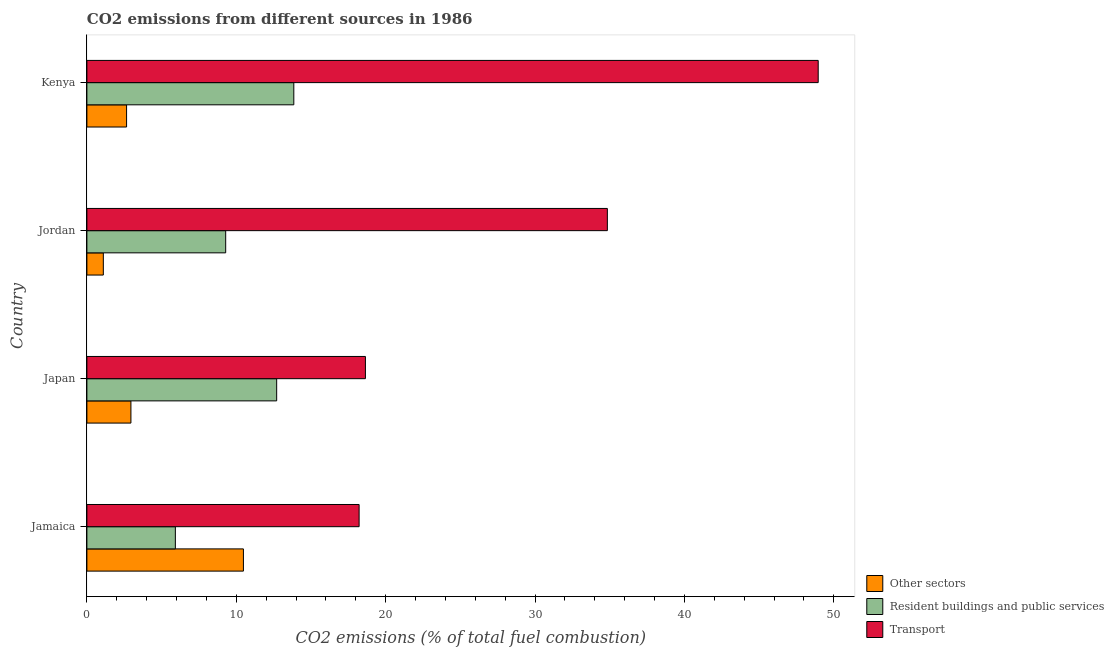How many different coloured bars are there?
Ensure brevity in your answer.  3. How many groups of bars are there?
Keep it short and to the point. 4. Are the number of bars on each tick of the Y-axis equal?
Make the answer very short. Yes. How many bars are there on the 1st tick from the bottom?
Offer a very short reply. 3. In how many cases, is the number of bars for a given country not equal to the number of legend labels?
Offer a very short reply. 0. What is the percentage of co2 emissions from other sectors in Jordan?
Give a very brief answer. 1.1. Across all countries, what is the maximum percentage of co2 emissions from transport?
Your response must be concise. 48.96. Across all countries, what is the minimum percentage of co2 emissions from other sectors?
Provide a short and direct response. 1.1. In which country was the percentage of co2 emissions from resident buildings and public services maximum?
Make the answer very short. Kenya. In which country was the percentage of co2 emissions from resident buildings and public services minimum?
Give a very brief answer. Jamaica. What is the total percentage of co2 emissions from resident buildings and public services in the graph?
Make the answer very short. 41.77. What is the difference between the percentage of co2 emissions from resident buildings and public services in Japan and that in Kenya?
Your answer should be compact. -1.15. What is the difference between the percentage of co2 emissions from resident buildings and public services in Kenya and the percentage of co2 emissions from transport in Jamaica?
Offer a very short reply. -4.37. What is the average percentage of co2 emissions from resident buildings and public services per country?
Keep it short and to the point. 10.44. What is the difference between the percentage of co2 emissions from transport and percentage of co2 emissions from resident buildings and public services in Japan?
Keep it short and to the point. 5.94. What is the ratio of the percentage of co2 emissions from resident buildings and public services in Jordan to that in Kenya?
Provide a short and direct response. 0.67. What is the difference between the highest and the second highest percentage of co2 emissions from other sectors?
Offer a very short reply. 7.53. What is the difference between the highest and the lowest percentage of co2 emissions from transport?
Keep it short and to the point. 30.73. In how many countries, is the percentage of co2 emissions from resident buildings and public services greater than the average percentage of co2 emissions from resident buildings and public services taken over all countries?
Offer a terse response. 2. What does the 2nd bar from the top in Jordan represents?
Make the answer very short. Resident buildings and public services. What does the 2nd bar from the bottom in Jordan represents?
Provide a short and direct response. Resident buildings and public services. How many bars are there?
Give a very brief answer. 12. Are all the bars in the graph horizontal?
Offer a very short reply. Yes. Does the graph contain any zero values?
Provide a short and direct response. No. Where does the legend appear in the graph?
Offer a terse response. Bottom right. How many legend labels are there?
Your response must be concise. 3. How are the legend labels stacked?
Your response must be concise. Vertical. What is the title of the graph?
Keep it short and to the point. CO2 emissions from different sources in 1986. What is the label or title of the X-axis?
Your response must be concise. CO2 emissions (% of total fuel combustion). What is the label or title of the Y-axis?
Make the answer very short. Country. What is the CO2 emissions (% of total fuel combustion) in Other sectors in Jamaica?
Offer a terse response. 10.48. What is the CO2 emissions (% of total fuel combustion) of Resident buildings and public services in Jamaica?
Your answer should be compact. 5.92. What is the CO2 emissions (% of total fuel combustion) of Transport in Jamaica?
Offer a terse response. 18.22. What is the CO2 emissions (% of total fuel combustion) in Other sectors in Japan?
Make the answer very short. 2.95. What is the CO2 emissions (% of total fuel combustion) in Resident buildings and public services in Japan?
Your answer should be very brief. 12.7. What is the CO2 emissions (% of total fuel combustion) in Transport in Japan?
Offer a terse response. 18.65. What is the CO2 emissions (% of total fuel combustion) of Other sectors in Jordan?
Provide a short and direct response. 1.1. What is the CO2 emissions (% of total fuel combustion) in Resident buildings and public services in Jordan?
Your response must be concise. 9.29. What is the CO2 emissions (% of total fuel combustion) in Transport in Jordan?
Make the answer very short. 34.84. What is the CO2 emissions (% of total fuel combustion) of Other sectors in Kenya?
Ensure brevity in your answer.  2.66. What is the CO2 emissions (% of total fuel combustion) of Resident buildings and public services in Kenya?
Your response must be concise. 13.85. What is the CO2 emissions (% of total fuel combustion) of Transport in Kenya?
Provide a succinct answer. 48.96. Across all countries, what is the maximum CO2 emissions (% of total fuel combustion) of Other sectors?
Your answer should be very brief. 10.48. Across all countries, what is the maximum CO2 emissions (% of total fuel combustion) in Resident buildings and public services?
Your answer should be very brief. 13.85. Across all countries, what is the maximum CO2 emissions (% of total fuel combustion) in Transport?
Your answer should be compact. 48.96. Across all countries, what is the minimum CO2 emissions (% of total fuel combustion) in Other sectors?
Offer a very short reply. 1.1. Across all countries, what is the minimum CO2 emissions (% of total fuel combustion) of Resident buildings and public services?
Provide a succinct answer. 5.92. Across all countries, what is the minimum CO2 emissions (% of total fuel combustion) of Transport?
Provide a short and direct response. 18.22. What is the total CO2 emissions (% of total fuel combustion) of Other sectors in the graph?
Provide a succinct answer. 17.18. What is the total CO2 emissions (% of total fuel combustion) in Resident buildings and public services in the graph?
Keep it short and to the point. 41.77. What is the total CO2 emissions (% of total fuel combustion) in Transport in the graph?
Give a very brief answer. 120.67. What is the difference between the CO2 emissions (% of total fuel combustion) of Other sectors in Jamaica and that in Japan?
Give a very brief answer. 7.53. What is the difference between the CO2 emissions (% of total fuel combustion) in Resident buildings and public services in Jamaica and that in Japan?
Offer a very short reply. -6.78. What is the difference between the CO2 emissions (% of total fuel combustion) of Transport in Jamaica and that in Japan?
Provide a succinct answer. -0.42. What is the difference between the CO2 emissions (% of total fuel combustion) of Other sectors in Jamaica and that in Jordan?
Make the answer very short. 9.38. What is the difference between the CO2 emissions (% of total fuel combustion) in Resident buildings and public services in Jamaica and that in Jordan?
Ensure brevity in your answer.  -3.37. What is the difference between the CO2 emissions (% of total fuel combustion) in Transport in Jamaica and that in Jordan?
Give a very brief answer. -16.62. What is the difference between the CO2 emissions (% of total fuel combustion) of Other sectors in Jamaica and that in Kenya?
Your response must be concise. 7.82. What is the difference between the CO2 emissions (% of total fuel combustion) in Resident buildings and public services in Jamaica and that in Kenya?
Provide a short and direct response. -7.93. What is the difference between the CO2 emissions (% of total fuel combustion) in Transport in Jamaica and that in Kenya?
Your response must be concise. -30.73. What is the difference between the CO2 emissions (% of total fuel combustion) of Other sectors in Japan and that in Jordan?
Ensure brevity in your answer.  1.85. What is the difference between the CO2 emissions (% of total fuel combustion) of Resident buildings and public services in Japan and that in Jordan?
Provide a short and direct response. 3.41. What is the difference between the CO2 emissions (% of total fuel combustion) in Transport in Japan and that in Jordan?
Keep it short and to the point. -16.2. What is the difference between the CO2 emissions (% of total fuel combustion) in Other sectors in Japan and that in Kenya?
Offer a very short reply. 0.29. What is the difference between the CO2 emissions (% of total fuel combustion) of Resident buildings and public services in Japan and that in Kenya?
Your answer should be very brief. -1.15. What is the difference between the CO2 emissions (% of total fuel combustion) of Transport in Japan and that in Kenya?
Your answer should be compact. -30.31. What is the difference between the CO2 emissions (% of total fuel combustion) of Other sectors in Jordan and that in Kenya?
Ensure brevity in your answer.  -1.56. What is the difference between the CO2 emissions (% of total fuel combustion) of Resident buildings and public services in Jordan and that in Kenya?
Your response must be concise. -4.56. What is the difference between the CO2 emissions (% of total fuel combustion) of Transport in Jordan and that in Kenya?
Keep it short and to the point. -14.12. What is the difference between the CO2 emissions (% of total fuel combustion) in Other sectors in Jamaica and the CO2 emissions (% of total fuel combustion) in Resident buildings and public services in Japan?
Your response must be concise. -2.23. What is the difference between the CO2 emissions (% of total fuel combustion) in Other sectors in Jamaica and the CO2 emissions (% of total fuel combustion) in Transport in Japan?
Make the answer very short. -8.17. What is the difference between the CO2 emissions (% of total fuel combustion) of Resident buildings and public services in Jamaica and the CO2 emissions (% of total fuel combustion) of Transport in Japan?
Ensure brevity in your answer.  -12.72. What is the difference between the CO2 emissions (% of total fuel combustion) in Other sectors in Jamaica and the CO2 emissions (% of total fuel combustion) in Resident buildings and public services in Jordan?
Your answer should be very brief. 1.19. What is the difference between the CO2 emissions (% of total fuel combustion) in Other sectors in Jamaica and the CO2 emissions (% of total fuel combustion) in Transport in Jordan?
Offer a very short reply. -24.36. What is the difference between the CO2 emissions (% of total fuel combustion) in Resident buildings and public services in Jamaica and the CO2 emissions (% of total fuel combustion) in Transport in Jordan?
Ensure brevity in your answer.  -28.92. What is the difference between the CO2 emissions (% of total fuel combustion) of Other sectors in Jamaica and the CO2 emissions (% of total fuel combustion) of Resident buildings and public services in Kenya?
Offer a terse response. -3.37. What is the difference between the CO2 emissions (% of total fuel combustion) of Other sectors in Jamaica and the CO2 emissions (% of total fuel combustion) of Transport in Kenya?
Provide a succinct answer. -38.48. What is the difference between the CO2 emissions (% of total fuel combustion) of Resident buildings and public services in Jamaica and the CO2 emissions (% of total fuel combustion) of Transport in Kenya?
Ensure brevity in your answer.  -43.03. What is the difference between the CO2 emissions (% of total fuel combustion) of Other sectors in Japan and the CO2 emissions (% of total fuel combustion) of Resident buildings and public services in Jordan?
Keep it short and to the point. -6.34. What is the difference between the CO2 emissions (% of total fuel combustion) of Other sectors in Japan and the CO2 emissions (% of total fuel combustion) of Transport in Jordan?
Your answer should be compact. -31.89. What is the difference between the CO2 emissions (% of total fuel combustion) of Resident buildings and public services in Japan and the CO2 emissions (% of total fuel combustion) of Transport in Jordan?
Provide a short and direct response. -22.14. What is the difference between the CO2 emissions (% of total fuel combustion) of Other sectors in Japan and the CO2 emissions (% of total fuel combustion) of Resident buildings and public services in Kenya?
Make the answer very short. -10.9. What is the difference between the CO2 emissions (% of total fuel combustion) of Other sectors in Japan and the CO2 emissions (% of total fuel combustion) of Transport in Kenya?
Offer a terse response. -46.01. What is the difference between the CO2 emissions (% of total fuel combustion) in Resident buildings and public services in Japan and the CO2 emissions (% of total fuel combustion) in Transport in Kenya?
Offer a very short reply. -36.25. What is the difference between the CO2 emissions (% of total fuel combustion) of Other sectors in Jordan and the CO2 emissions (% of total fuel combustion) of Resident buildings and public services in Kenya?
Make the answer very short. -12.75. What is the difference between the CO2 emissions (% of total fuel combustion) in Other sectors in Jordan and the CO2 emissions (% of total fuel combustion) in Transport in Kenya?
Make the answer very short. -47.86. What is the difference between the CO2 emissions (% of total fuel combustion) in Resident buildings and public services in Jordan and the CO2 emissions (% of total fuel combustion) in Transport in Kenya?
Offer a very short reply. -39.67. What is the average CO2 emissions (% of total fuel combustion) of Other sectors per country?
Offer a very short reply. 4.3. What is the average CO2 emissions (% of total fuel combustion) of Resident buildings and public services per country?
Your response must be concise. 10.44. What is the average CO2 emissions (% of total fuel combustion) in Transport per country?
Ensure brevity in your answer.  30.17. What is the difference between the CO2 emissions (% of total fuel combustion) of Other sectors and CO2 emissions (% of total fuel combustion) of Resident buildings and public services in Jamaica?
Your answer should be compact. 4.56. What is the difference between the CO2 emissions (% of total fuel combustion) of Other sectors and CO2 emissions (% of total fuel combustion) of Transport in Jamaica?
Offer a terse response. -7.74. What is the difference between the CO2 emissions (% of total fuel combustion) of Resident buildings and public services and CO2 emissions (% of total fuel combustion) of Transport in Jamaica?
Ensure brevity in your answer.  -12.3. What is the difference between the CO2 emissions (% of total fuel combustion) of Other sectors and CO2 emissions (% of total fuel combustion) of Resident buildings and public services in Japan?
Offer a very short reply. -9.76. What is the difference between the CO2 emissions (% of total fuel combustion) of Other sectors and CO2 emissions (% of total fuel combustion) of Transport in Japan?
Provide a short and direct response. -15.7. What is the difference between the CO2 emissions (% of total fuel combustion) in Resident buildings and public services and CO2 emissions (% of total fuel combustion) in Transport in Japan?
Make the answer very short. -5.94. What is the difference between the CO2 emissions (% of total fuel combustion) of Other sectors and CO2 emissions (% of total fuel combustion) of Resident buildings and public services in Jordan?
Give a very brief answer. -8.19. What is the difference between the CO2 emissions (% of total fuel combustion) of Other sectors and CO2 emissions (% of total fuel combustion) of Transport in Jordan?
Offer a very short reply. -33.74. What is the difference between the CO2 emissions (% of total fuel combustion) of Resident buildings and public services and CO2 emissions (% of total fuel combustion) of Transport in Jordan?
Ensure brevity in your answer.  -25.55. What is the difference between the CO2 emissions (% of total fuel combustion) in Other sectors and CO2 emissions (% of total fuel combustion) in Resident buildings and public services in Kenya?
Your answer should be very brief. -11.2. What is the difference between the CO2 emissions (% of total fuel combustion) of Other sectors and CO2 emissions (% of total fuel combustion) of Transport in Kenya?
Your answer should be compact. -46.3. What is the difference between the CO2 emissions (% of total fuel combustion) of Resident buildings and public services and CO2 emissions (% of total fuel combustion) of Transport in Kenya?
Provide a succinct answer. -35.1. What is the ratio of the CO2 emissions (% of total fuel combustion) in Other sectors in Jamaica to that in Japan?
Provide a short and direct response. 3.56. What is the ratio of the CO2 emissions (% of total fuel combustion) of Resident buildings and public services in Jamaica to that in Japan?
Your response must be concise. 0.47. What is the ratio of the CO2 emissions (% of total fuel combustion) in Transport in Jamaica to that in Japan?
Provide a short and direct response. 0.98. What is the ratio of the CO2 emissions (% of total fuel combustion) in Other sectors in Jamaica to that in Jordan?
Give a very brief answer. 9.52. What is the ratio of the CO2 emissions (% of total fuel combustion) of Resident buildings and public services in Jamaica to that in Jordan?
Ensure brevity in your answer.  0.64. What is the ratio of the CO2 emissions (% of total fuel combustion) of Transport in Jamaica to that in Jordan?
Make the answer very short. 0.52. What is the ratio of the CO2 emissions (% of total fuel combustion) in Other sectors in Jamaica to that in Kenya?
Your answer should be very brief. 3.94. What is the ratio of the CO2 emissions (% of total fuel combustion) in Resident buildings and public services in Jamaica to that in Kenya?
Keep it short and to the point. 0.43. What is the ratio of the CO2 emissions (% of total fuel combustion) in Transport in Jamaica to that in Kenya?
Give a very brief answer. 0.37. What is the ratio of the CO2 emissions (% of total fuel combustion) of Other sectors in Japan to that in Jordan?
Provide a short and direct response. 2.68. What is the ratio of the CO2 emissions (% of total fuel combustion) of Resident buildings and public services in Japan to that in Jordan?
Your response must be concise. 1.37. What is the ratio of the CO2 emissions (% of total fuel combustion) of Transport in Japan to that in Jordan?
Your response must be concise. 0.54. What is the ratio of the CO2 emissions (% of total fuel combustion) in Other sectors in Japan to that in Kenya?
Give a very brief answer. 1.11. What is the ratio of the CO2 emissions (% of total fuel combustion) in Resident buildings and public services in Japan to that in Kenya?
Your response must be concise. 0.92. What is the ratio of the CO2 emissions (% of total fuel combustion) in Transport in Japan to that in Kenya?
Your answer should be compact. 0.38. What is the ratio of the CO2 emissions (% of total fuel combustion) in Other sectors in Jordan to that in Kenya?
Make the answer very short. 0.41. What is the ratio of the CO2 emissions (% of total fuel combustion) of Resident buildings and public services in Jordan to that in Kenya?
Offer a very short reply. 0.67. What is the ratio of the CO2 emissions (% of total fuel combustion) in Transport in Jordan to that in Kenya?
Offer a very short reply. 0.71. What is the difference between the highest and the second highest CO2 emissions (% of total fuel combustion) of Other sectors?
Offer a very short reply. 7.53. What is the difference between the highest and the second highest CO2 emissions (% of total fuel combustion) of Resident buildings and public services?
Keep it short and to the point. 1.15. What is the difference between the highest and the second highest CO2 emissions (% of total fuel combustion) in Transport?
Your answer should be very brief. 14.12. What is the difference between the highest and the lowest CO2 emissions (% of total fuel combustion) in Other sectors?
Give a very brief answer. 9.38. What is the difference between the highest and the lowest CO2 emissions (% of total fuel combustion) of Resident buildings and public services?
Give a very brief answer. 7.93. What is the difference between the highest and the lowest CO2 emissions (% of total fuel combustion) of Transport?
Your response must be concise. 30.73. 